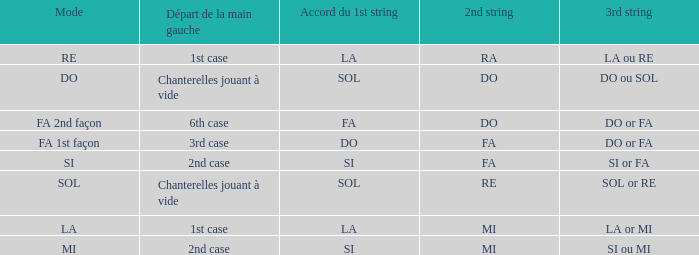What is the Depart de la main gauche of the do Mode? Chanterelles jouant à vide. 